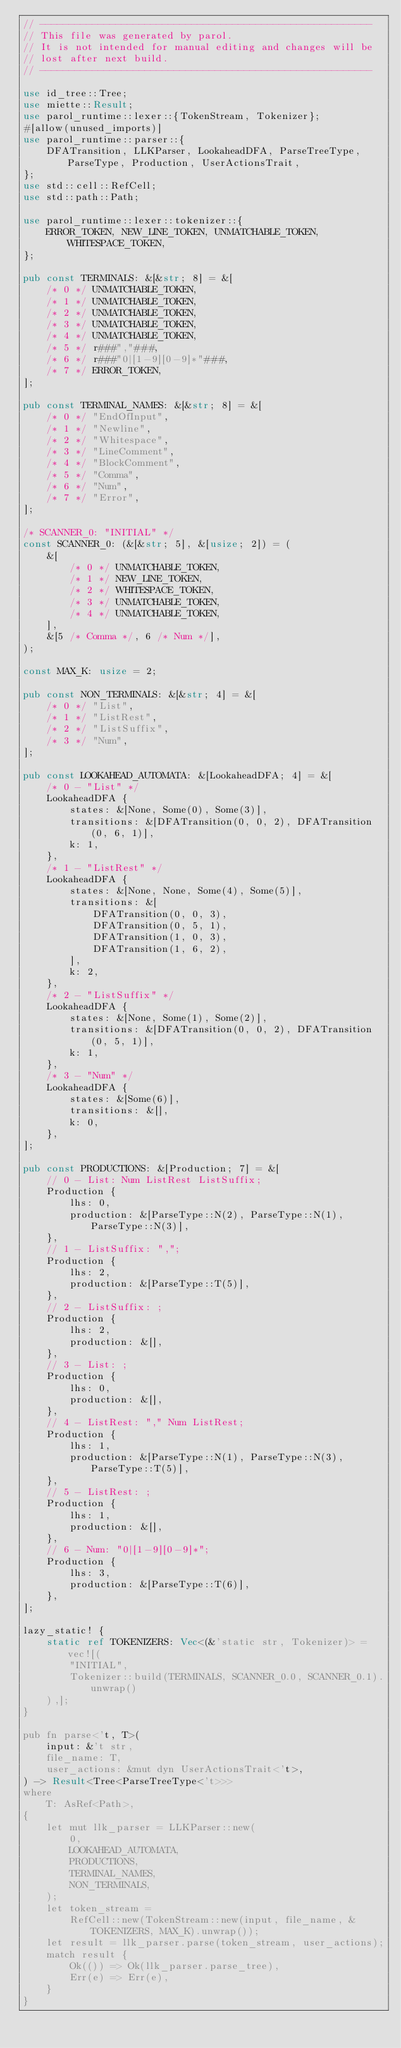Convert code to text. <code><loc_0><loc_0><loc_500><loc_500><_Rust_>// ---------------------------------------------------------
// This file was generated by parol.
// It is not intended for manual editing and changes will be
// lost after next build.
// ---------------------------------------------------------

use id_tree::Tree;
use miette::Result;
use parol_runtime::lexer::{TokenStream, Tokenizer};
#[allow(unused_imports)]
use parol_runtime::parser::{
    DFATransition, LLKParser, LookaheadDFA, ParseTreeType, ParseType, Production, UserActionsTrait,
};
use std::cell::RefCell;
use std::path::Path;

use parol_runtime::lexer::tokenizer::{
    ERROR_TOKEN, NEW_LINE_TOKEN, UNMATCHABLE_TOKEN, WHITESPACE_TOKEN,
};

pub const TERMINALS: &[&str; 8] = &[
    /* 0 */ UNMATCHABLE_TOKEN,
    /* 1 */ UNMATCHABLE_TOKEN,
    /* 2 */ UNMATCHABLE_TOKEN,
    /* 3 */ UNMATCHABLE_TOKEN,
    /* 4 */ UNMATCHABLE_TOKEN,
    /* 5 */ r###","###,
    /* 6 */ r###"0|[1-9][0-9]*"###,
    /* 7 */ ERROR_TOKEN,
];

pub const TERMINAL_NAMES: &[&str; 8] = &[
    /* 0 */ "EndOfInput",
    /* 1 */ "Newline",
    /* 2 */ "Whitespace",
    /* 3 */ "LineComment",
    /* 4 */ "BlockComment",
    /* 5 */ "Comma",
    /* 6 */ "Num",
    /* 7 */ "Error",
];

/* SCANNER_0: "INITIAL" */
const SCANNER_0: (&[&str; 5], &[usize; 2]) = (
    &[
        /* 0 */ UNMATCHABLE_TOKEN,
        /* 1 */ NEW_LINE_TOKEN,
        /* 2 */ WHITESPACE_TOKEN,
        /* 3 */ UNMATCHABLE_TOKEN,
        /* 4 */ UNMATCHABLE_TOKEN,
    ],
    &[5 /* Comma */, 6 /* Num */],
);

const MAX_K: usize = 2;

pub const NON_TERMINALS: &[&str; 4] = &[
    /* 0 */ "List",
    /* 1 */ "ListRest",
    /* 2 */ "ListSuffix",
    /* 3 */ "Num",
];

pub const LOOKAHEAD_AUTOMATA: &[LookaheadDFA; 4] = &[
    /* 0 - "List" */
    LookaheadDFA {
        states: &[None, Some(0), Some(3)],
        transitions: &[DFATransition(0, 0, 2), DFATransition(0, 6, 1)],
        k: 1,
    },
    /* 1 - "ListRest" */
    LookaheadDFA {
        states: &[None, None, Some(4), Some(5)],
        transitions: &[
            DFATransition(0, 0, 3),
            DFATransition(0, 5, 1),
            DFATransition(1, 0, 3),
            DFATransition(1, 6, 2),
        ],
        k: 2,
    },
    /* 2 - "ListSuffix" */
    LookaheadDFA {
        states: &[None, Some(1), Some(2)],
        transitions: &[DFATransition(0, 0, 2), DFATransition(0, 5, 1)],
        k: 1,
    },
    /* 3 - "Num" */
    LookaheadDFA {
        states: &[Some(6)],
        transitions: &[],
        k: 0,
    },
];

pub const PRODUCTIONS: &[Production; 7] = &[
    // 0 - List: Num ListRest ListSuffix;
    Production {
        lhs: 0,
        production: &[ParseType::N(2), ParseType::N(1), ParseType::N(3)],
    },
    // 1 - ListSuffix: ",";
    Production {
        lhs: 2,
        production: &[ParseType::T(5)],
    },
    // 2 - ListSuffix: ;
    Production {
        lhs: 2,
        production: &[],
    },
    // 3 - List: ;
    Production {
        lhs: 0,
        production: &[],
    },
    // 4 - ListRest: "," Num ListRest;
    Production {
        lhs: 1,
        production: &[ParseType::N(1), ParseType::N(3), ParseType::T(5)],
    },
    // 5 - ListRest: ;
    Production {
        lhs: 1,
        production: &[],
    },
    // 6 - Num: "0|[1-9][0-9]*";
    Production {
        lhs: 3,
        production: &[ParseType::T(6)],
    },
];

lazy_static! {
    static ref TOKENIZERS: Vec<(&'static str, Tokenizer)> = vec![(
        "INITIAL",
        Tokenizer::build(TERMINALS, SCANNER_0.0, SCANNER_0.1).unwrap()
    ),];
}

pub fn parse<'t, T>(
    input: &'t str,
    file_name: T,
    user_actions: &mut dyn UserActionsTrait<'t>,
) -> Result<Tree<ParseTreeType<'t>>>
where
    T: AsRef<Path>,
{
    let mut llk_parser = LLKParser::new(
        0,
        LOOKAHEAD_AUTOMATA,
        PRODUCTIONS,
        TERMINAL_NAMES,
        NON_TERMINALS,
    );
    let token_stream =
        RefCell::new(TokenStream::new(input, file_name, &TOKENIZERS, MAX_K).unwrap());
    let result = llk_parser.parse(token_stream, user_actions);
    match result {
        Ok(()) => Ok(llk_parser.parse_tree),
        Err(e) => Err(e),
    }
}
</code> 